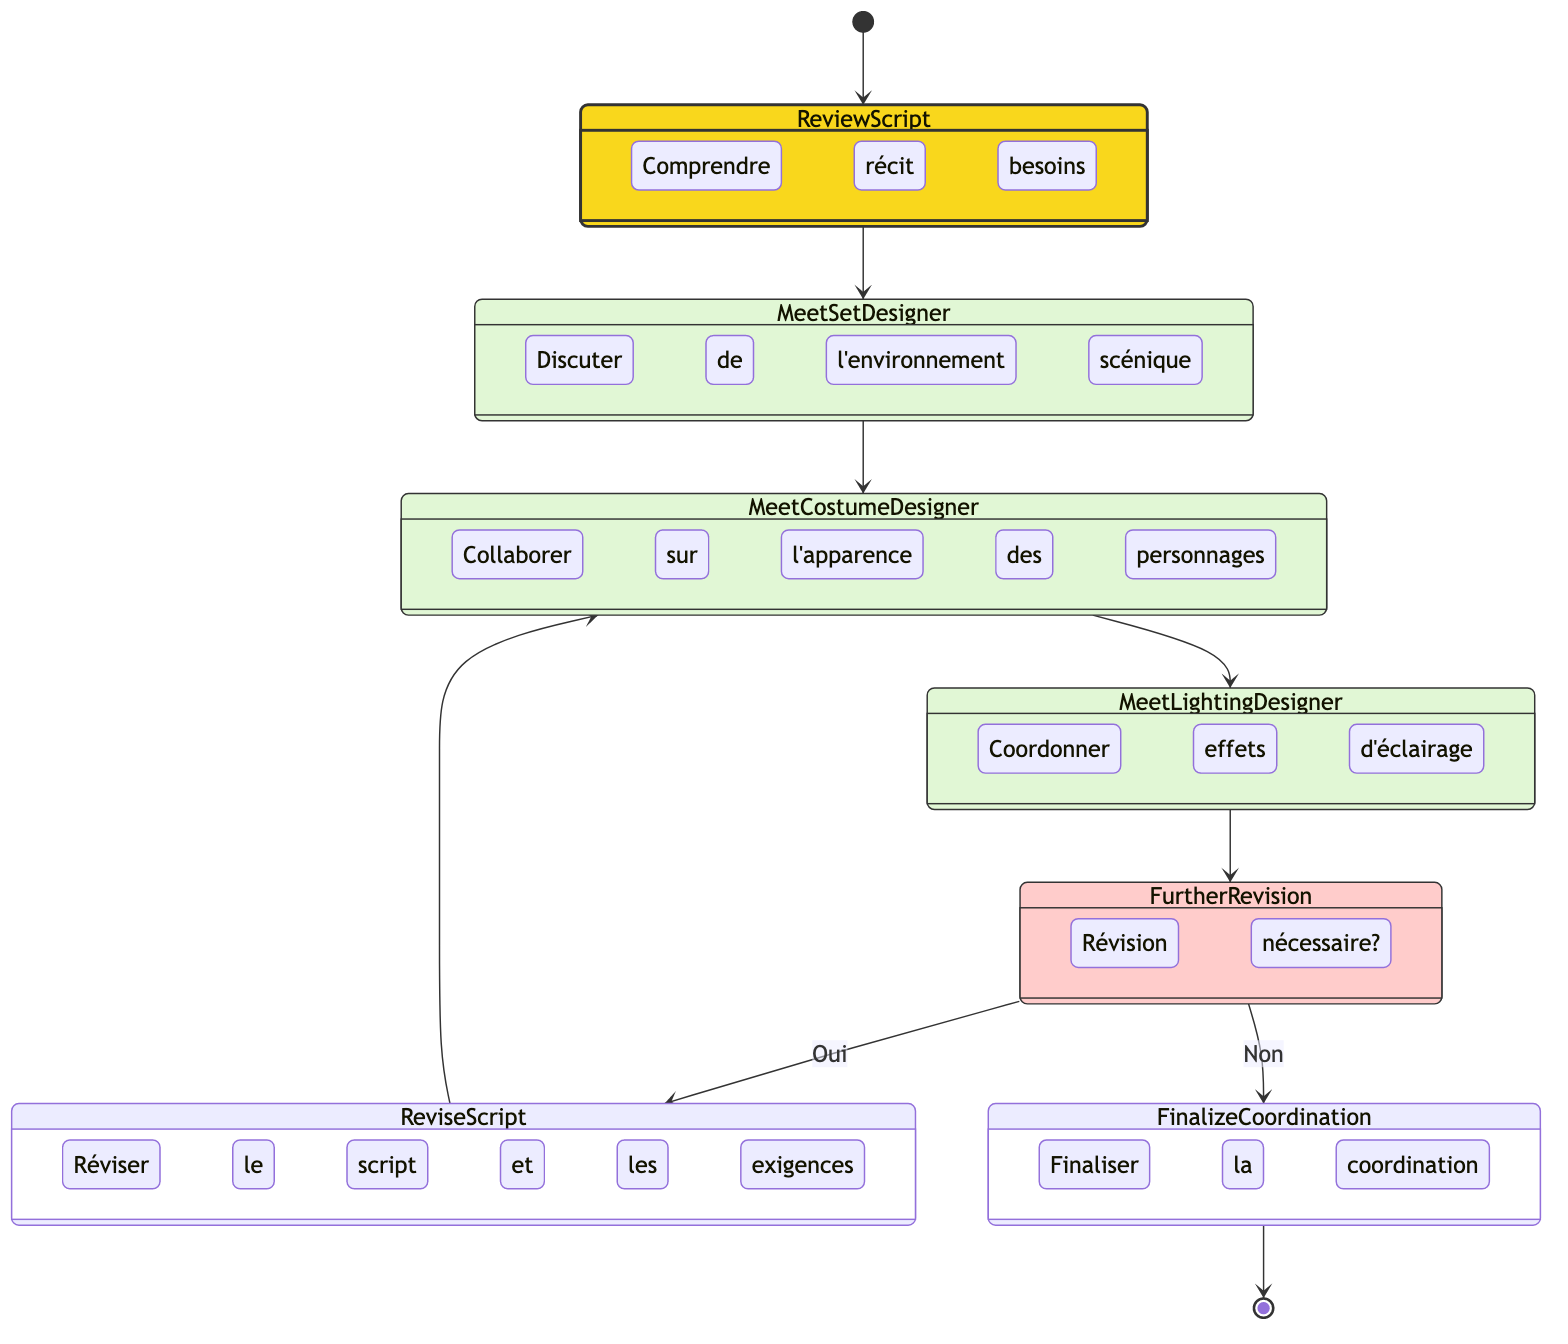What is the initial activity in the diagram? The diagram starts with the "Begin Coordination Process," which is the first step indicated by the arrow leading from the start symbol to this activity.
Answer: Begin Coordination Process How many main activities are present in the diagram? The diagram contains four main activities: "Review Script," "Meet Set Designer," "Meet Costume Designer," and "Meet Lighting Designer." Counting these gives a total of four activities.
Answer: 4 What decision point is included in the diagram? The decision point in the diagram is labeled "Is Further Revision Needed?" and is shown as a diamond shape indicating it requires a yes or no response to proceed.
Answer: Is Further Revision Needed? If revisions are needed, which activity follows? If revisions are needed, the next activity that follows the decision is "Revise Script and Requirements," as indicated by the flow from the decision point to this activity.
Answer: Revise Script and Requirements What happens after meeting the lighting designer if no revision is needed? If no revision is needed after meeting the lighting designer, the process flows directly to "Finalize Coordination," indicating that all departments are aligned and ready for production.
Answer: Finalize Coordination What does the decision "Is Further Revision Needed?" lead to if the answer is yes? If the answer to "Is Further Revision Needed?" is yes, it leads to "Revise Script and Requirements," meaning that adjustments must be made before proceeding.
Answer: Revise Script and Requirements How many total transitions are present in the diagram? The diagram shows a total of seven transitions, which include the flow from one activity to another as well as the decision branches. Counting them gives a total of seven transitions.
Answer: 7 What does the diagram convey about the collaboration process? The diagram conveys that coordinating with different design departments involves a series of meetings and discussions, culminating in possible revisions before finalizing the production details.
Answer: Coordination process involves meetings and revisions 